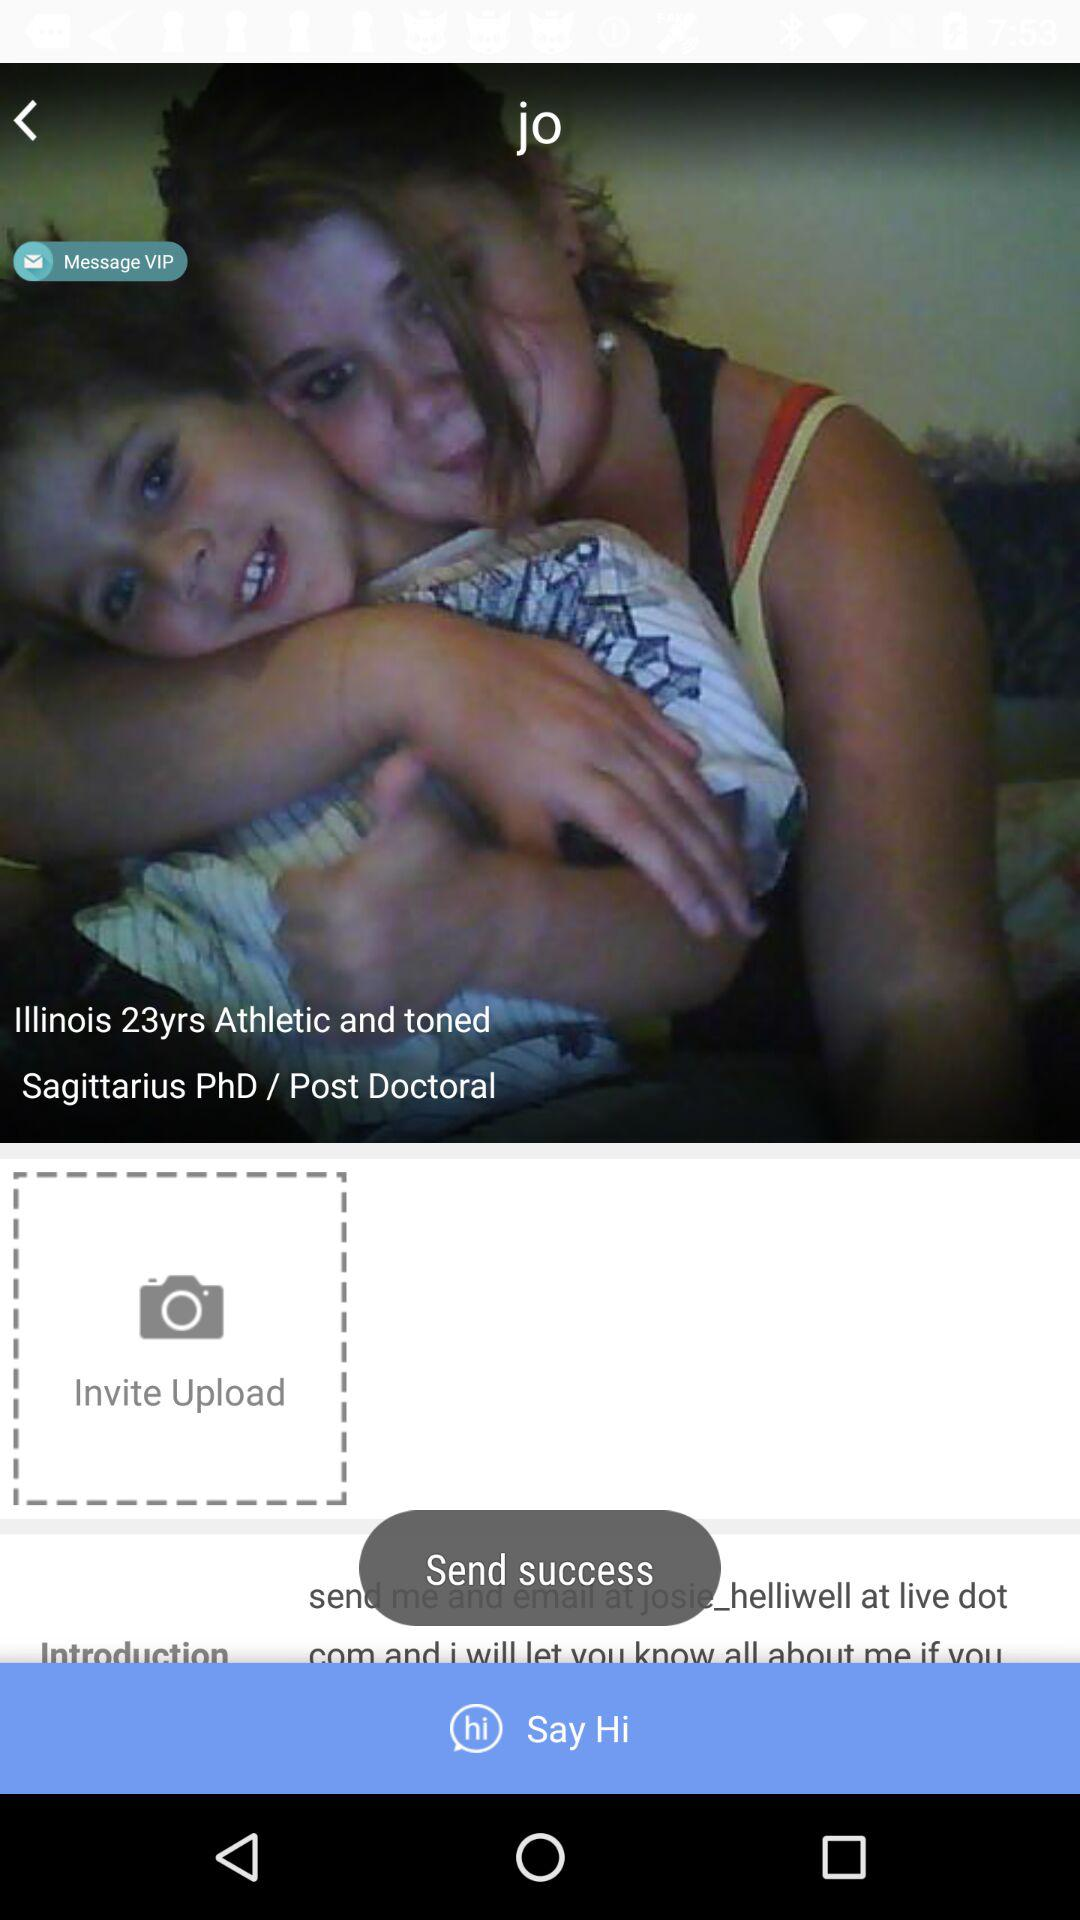What is the zodiac sign? The zodiac sign is Sagittarius. 